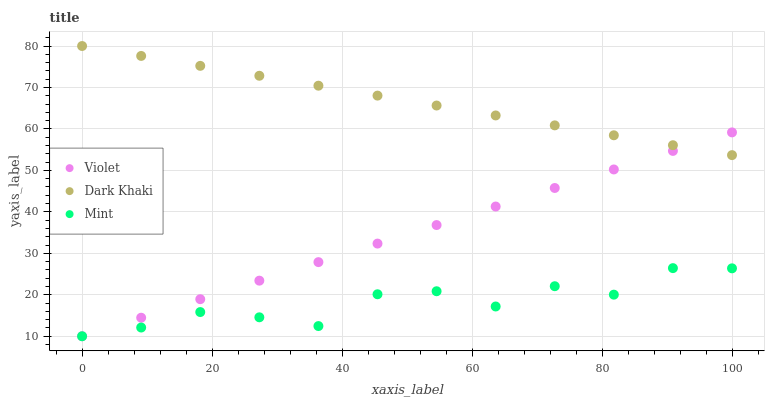Does Mint have the minimum area under the curve?
Answer yes or no. Yes. Does Dark Khaki have the maximum area under the curve?
Answer yes or no. Yes. Does Violet have the minimum area under the curve?
Answer yes or no. No. Does Violet have the maximum area under the curve?
Answer yes or no. No. Is Violet the smoothest?
Answer yes or no. Yes. Is Mint the roughest?
Answer yes or no. Yes. Is Mint the smoothest?
Answer yes or no. No. Is Violet the roughest?
Answer yes or no. No. Does Mint have the lowest value?
Answer yes or no. Yes. Does Dark Khaki have the highest value?
Answer yes or no. Yes. Does Violet have the highest value?
Answer yes or no. No. Is Mint less than Dark Khaki?
Answer yes or no. Yes. Is Dark Khaki greater than Mint?
Answer yes or no. Yes. Does Violet intersect Mint?
Answer yes or no. Yes. Is Violet less than Mint?
Answer yes or no. No. Is Violet greater than Mint?
Answer yes or no. No. Does Mint intersect Dark Khaki?
Answer yes or no. No. 